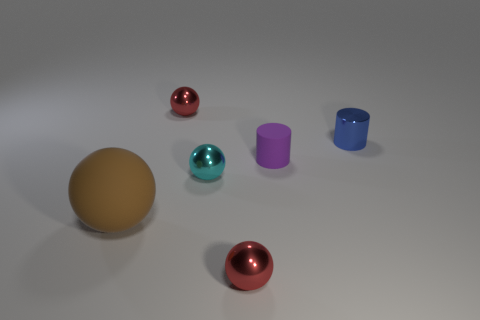Do the cyan sphere and the matte object that is behind the small cyan metallic thing have the same size?
Your answer should be compact. Yes. How many cyan balls are the same size as the blue object?
Offer a very short reply. 1. There is a tiny cylinder that is the same material as the tiny cyan ball; what color is it?
Your response must be concise. Blue. Are there more small blue things than tiny red metal cylinders?
Your response must be concise. Yes. Does the brown sphere have the same material as the tiny cyan ball?
Make the answer very short. No. The small purple object that is made of the same material as the big ball is what shape?
Offer a very short reply. Cylinder. Are there fewer gray metallic balls than brown objects?
Provide a short and direct response. Yes. There is a sphere that is both in front of the blue shiny thing and behind the brown matte sphere; what material is it?
Offer a very short reply. Metal. There is a red object in front of the small red metal ball behind the metallic object that is in front of the large rubber thing; what is its size?
Offer a very short reply. Small. There is a small blue metallic thing; does it have the same shape as the red thing that is behind the large rubber ball?
Offer a very short reply. No. 